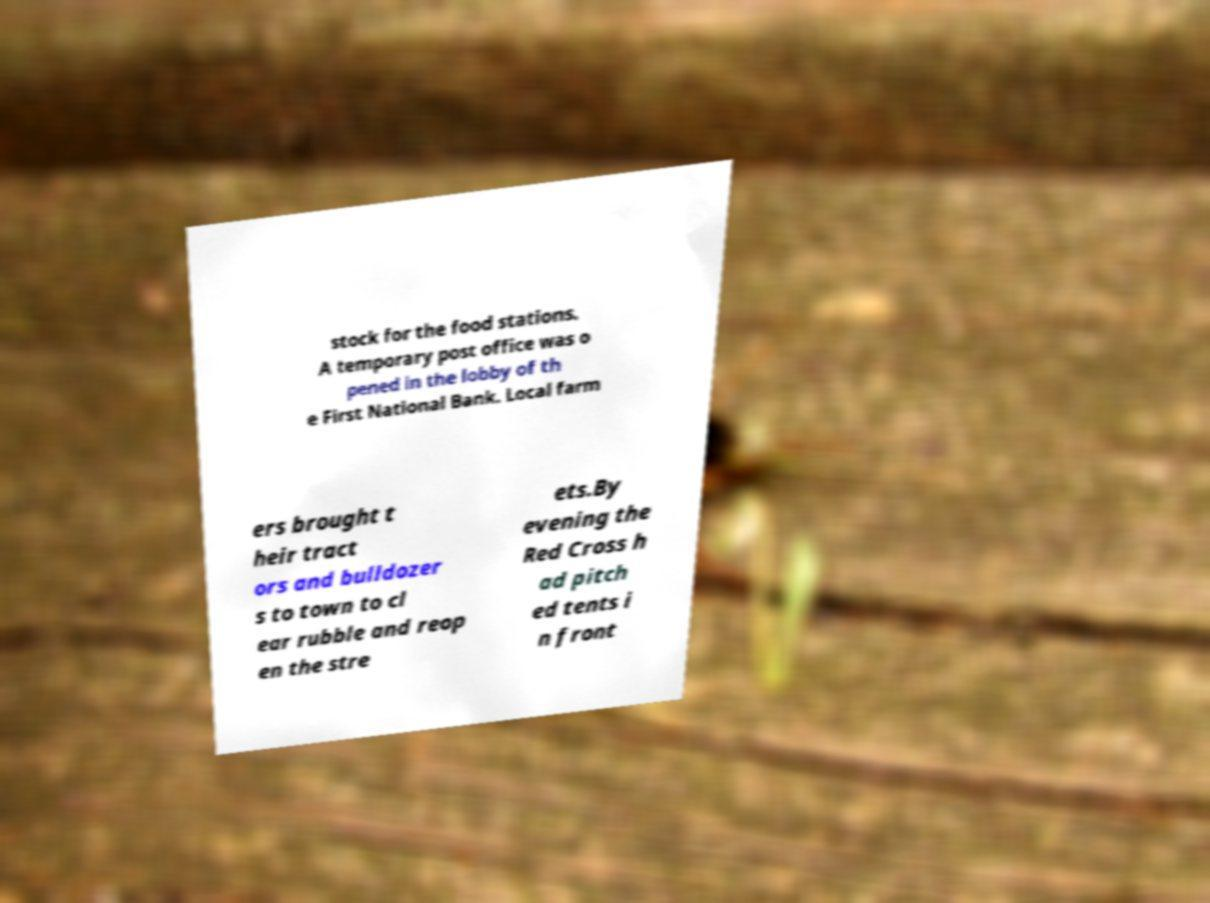Can you accurately transcribe the text from the provided image for me? stock for the food stations. A temporary post office was o pened in the lobby of th e First National Bank. Local farm ers brought t heir tract ors and bulldozer s to town to cl ear rubble and reop en the stre ets.By evening the Red Cross h ad pitch ed tents i n front 